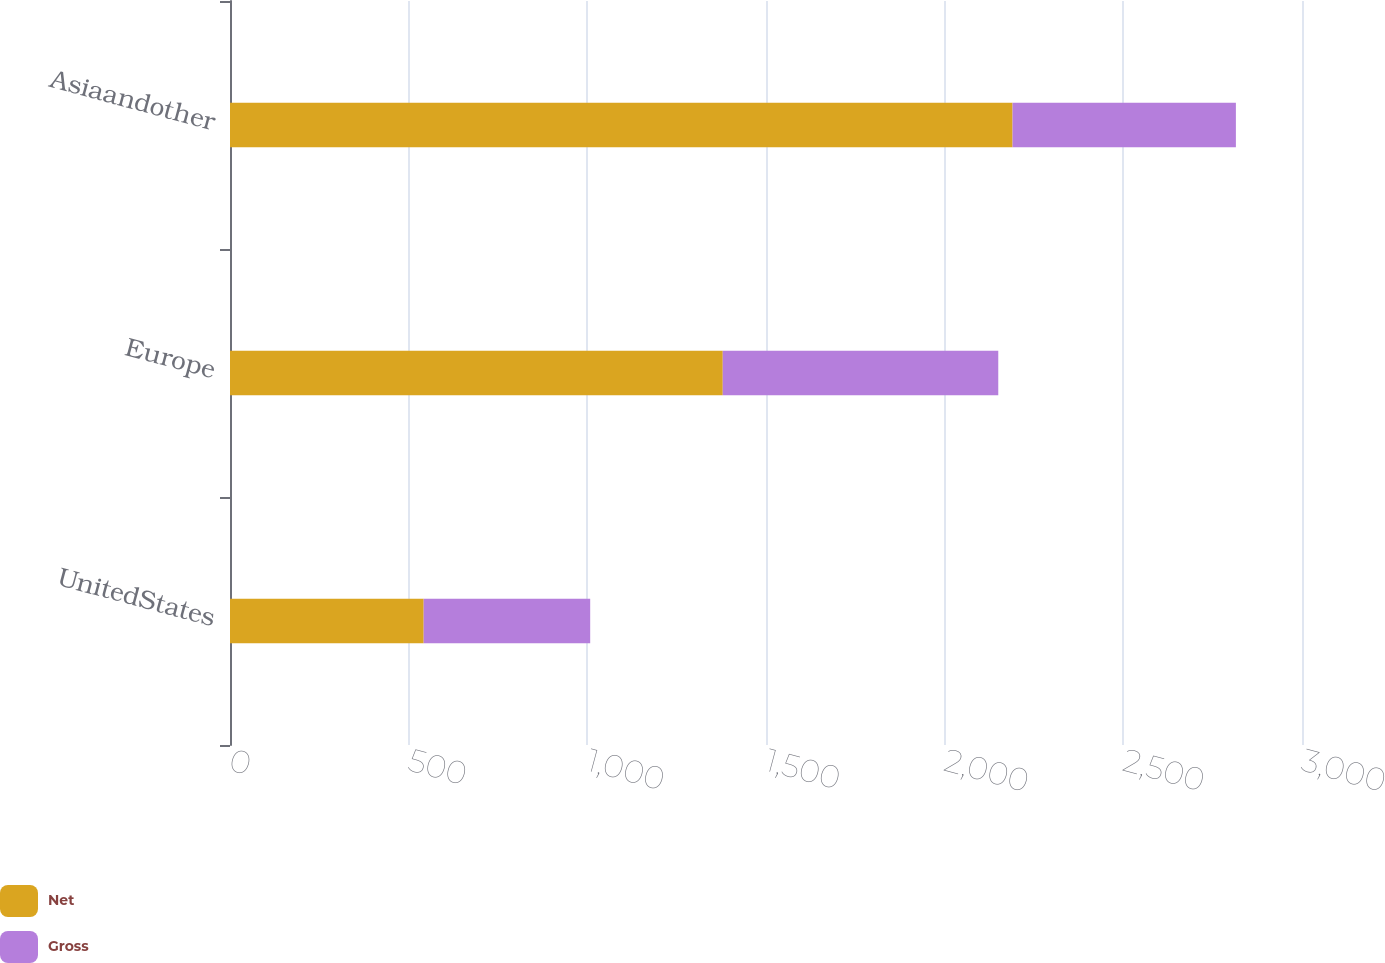<chart> <loc_0><loc_0><loc_500><loc_500><stacked_bar_chart><ecel><fcel>UnitedStates<fcel>Europe<fcel>Asiaandother<nl><fcel>Net<fcel>542<fcel>1379<fcel>2190<nl><fcel>Gross<fcel>466<fcel>771<fcel>625<nl></chart> 